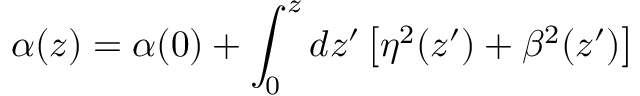<formula> <loc_0><loc_0><loc_500><loc_500>\alpha ( z ) = \alpha ( 0 ) + \int _ { 0 } ^ { z } d z ^ { \prime } \left [ \eta ^ { 2 } ( z ^ { \prime } ) + \beta ^ { 2 } ( z ^ { \prime } ) \right ]</formula> 